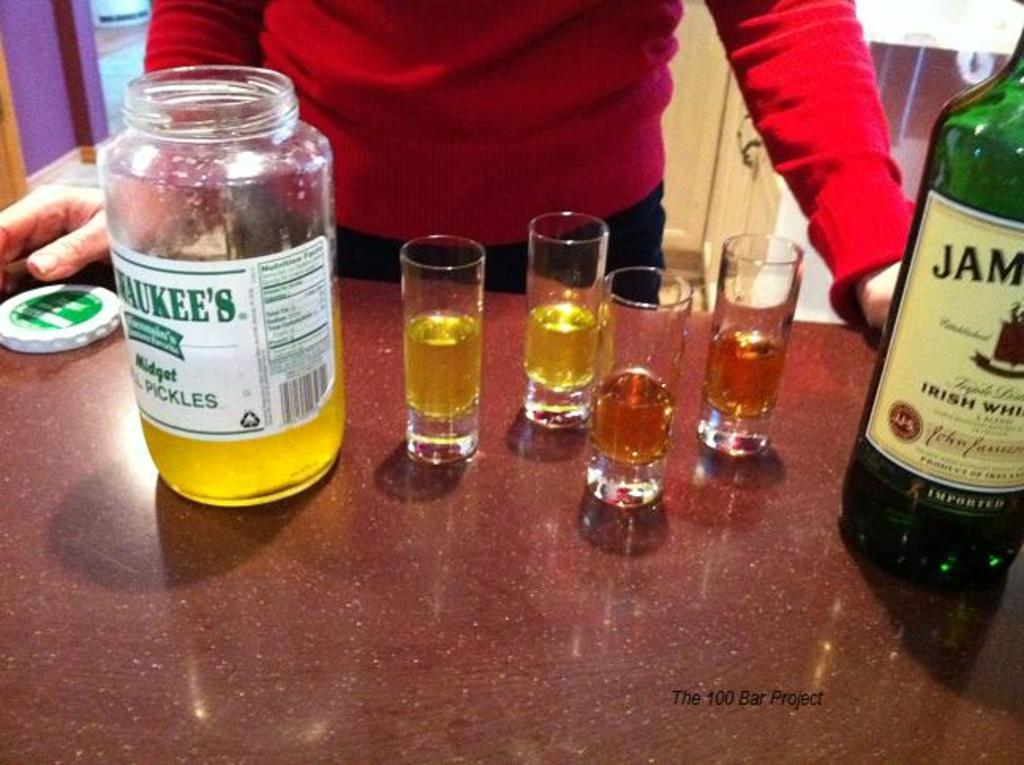<image>
Create a compact narrative representing the image presented. A jar of Milwaukee's pickles and 4 glasses of alcohol are on the table. 